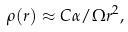<formula> <loc_0><loc_0><loc_500><loc_500>\rho ( r ) \approx { C \alpha } / { \Omega r ^ { 2 } } ,</formula> 